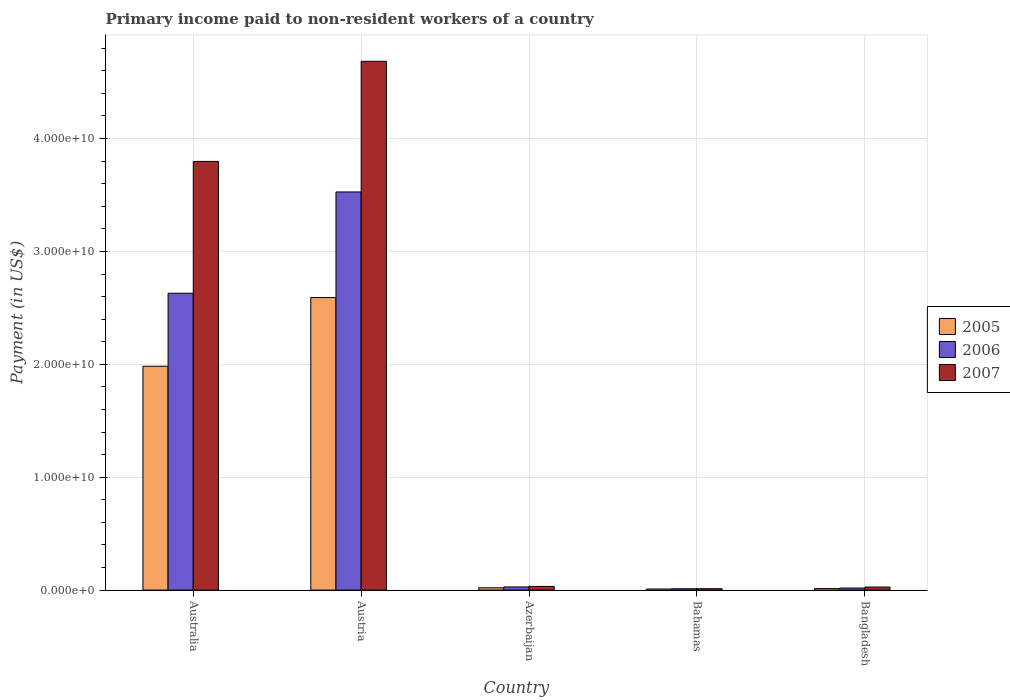How many groups of bars are there?
Provide a short and direct response. 5. Are the number of bars on each tick of the X-axis equal?
Offer a terse response. Yes. What is the label of the 4th group of bars from the left?
Keep it short and to the point. Bahamas. What is the amount paid to workers in 2006 in Bangladesh?
Offer a very short reply. 1.84e+08. Across all countries, what is the maximum amount paid to workers in 2007?
Offer a very short reply. 4.68e+1. Across all countries, what is the minimum amount paid to workers in 2006?
Ensure brevity in your answer.  1.19e+08. In which country was the amount paid to workers in 2007 maximum?
Make the answer very short. Austria. In which country was the amount paid to workers in 2007 minimum?
Ensure brevity in your answer.  Bahamas. What is the total amount paid to workers in 2005 in the graph?
Ensure brevity in your answer.  4.62e+1. What is the difference between the amount paid to workers in 2006 in Austria and that in Bahamas?
Offer a terse response. 3.52e+1. What is the difference between the amount paid to workers in 2006 in Azerbaijan and the amount paid to workers in 2007 in Bangladesh?
Ensure brevity in your answer.  8.32e+06. What is the average amount paid to workers in 2007 per country?
Make the answer very short. 1.71e+1. What is the difference between the amount paid to workers of/in 2006 and amount paid to workers of/in 2005 in Bangladesh?
Ensure brevity in your answer.  4.93e+07. What is the ratio of the amount paid to workers in 2005 in Bahamas to that in Bangladesh?
Your response must be concise. 0.72. Is the amount paid to workers in 2006 in Bahamas less than that in Bangladesh?
Offer a terse response. Yes. Is the difference between the amount paid to workers in 2006 in Austria and Bangladesh greater than the difference between the amount paid to workers in 2005 in Austria and Bangladesh?
Give a very brief answer. Yes. What is the difference between the highest and the second highest amount paid to workers in 2007?
Make the answer very short. 3.76e+1. What is the difference between the highest and the lowest amount paid to workers in 2005?
Make the answer very short. 2.58e+1. In how many countries, is the amount paid to workers in 2006 greater than the average amount paid to workers in 2006 taken over all countries?
Offer a very short reply. 2. Is the sum of the amount paid to workers in 2005 in Australia and Austria greater than the maximum amount paid to workers in 2007 across all countries?
Ensure brevity in your answer.  No. What does the 1st bar from the left in Australia represents?
Offer a terse response. 2005. What does the 3rd bar from the right in Austria represents?
Keep it short and to the point. 2005. Is it the case that in every country, the sum of the amount paid to workers in 2006 and amount paid to workers in 2005 is greater than the amount paid to workers in 2007?
Offer a very short reply. Yes. How many bars are there?
Your answer should be compact. 15. Are all the bars in the graph horizontal?
Provide a succinct answer. No. How many countries are there in the graph?
Provide a succinct answer. 5. What is the difference between two consecutive major ticks on the Y-axis?
Keep it short and to the point. 1.00e+1. Are the values on the major ticks of Y-axis written in scientific E-notation?
Ensure brevity in your answer.  Yes. Does the graph contain any zero values?
Ensure brevity in your answer.  No. Does the graph contain grids?
Ensure brevity in your answer.  Yes. How are the legend labels stacked?
Make the answer very short. Vertical. What is the title of the graph?
Provide a succinct answer. Primary income paid to non-resident workers of a country. What is the label or title of the Y-axis?
Give a very brief answer. Payment (in US$). What is the Payment (in US$) in 2005 in Australia?
Your answer should be compact. 1.98e+1. What is the Payment (in US$) of 2006 in Australia?
Keep it short and to the point. 2.63e+1. What is the Payment (in US$) of 2007 in Australia?
Provide a succinct answer. 3.80e+1. What is the Payment (in US$) in 2005 in Austria?
Give a very brief answer. 2.59e+1. What is the Payment (in US$) in 2006 in Austria?
Provide a succinct answer. 3.53e+1. What is the Payment (in US$) in 2007 in Austria?
Give a very brief answer. 4.68e+1. What is the Payment (in US$) in 2005 in Azerbaijan?
Offer a terse response. 2.02e+08. What is the Payment (in US$) in 2006 in Azerbaijan?
Offer a terse response. 2.80e+08. What is the Payment (in US$) of 2007 in Azerbaijan?
Your answer should be very brief. 3.28e+08. What is the Payment (in US$) of 2005 in Bahamas?
Offer a terse response. 9.70e+07. What is the Payment (in US$) in 2006 in Bahamas?
Ensure brevity in your answer.  1.19e+08. What is the Payment (in US$) in 2007 in Bahamas?
Offer a terse response. 1.21e+08. What is the Payment (in US$) of 2005 in Bangladesh?
Provide a succinct answer. 1.35e+08. What is the Payment (in US$) in 2006 in Bangladesh?
Provide a short and direct response. 1.84e+08. What is the Payment (in US$) in 2007 in Bangladesh?
Provide a short and direct response. 2.72e+08. Across all countries, what is the maximum Payment (in US$) in 2005?
Make the answer very short. 2.59e+1. Across all countries, what is the maximum Payment (in US$) in 2006?
Give a very brief answer. 3.53e+1. Across all countries, what is the maximum Payment (in US$) of 2007?
Offer a terse response. 4.68e+1. Across all countries, what is the minimum Payment (in US$) of 2005?
Make the answer very short. 9.70e+07. Across all countries, what is the minimum Payment (in US$) in 2006?
Your answer should be very brief. 1.19e+08. Across all countries, what is the minimum Payment (in US$) in 2007?
Ensure brevity in your answer.  1.21e+08. What is the total Payment (in US$) of 2005 in the graph?
Give a very brief answer. 4.62e+1. What is the total Payment (in US$) of 2006 in the graph?
Offer a very short reply. 6.22e+1. What is the total Payment (in US$) in 2007 in the graph?
Give a very brief answer. 8.55e+1. What is the difference between the Payment (in US$) of 2005 in Australia and that in Austria?
Provide a short and direct response. -6.09e+09. What is the difference between the Payment (in US$) of 2006 in Australia and that in Austria?
Offer a terse response. -8.97e+09. What is the difference between the Payment (in US$) of 2007 in Australia and that in Austria?
Give a very brief answer. -8.87e+09. What is the difference between the Payment (in US$) of 2005 in Australia and that in Azerbaijan?
Your response must be concise. 1.96e+1. What is the difference between the Payment (in US$) of 2006 in Australia and that in Azerbaijan?
Provide a succinct answer. 2.60e+1. What is the difference between the Payment (in US$) in 2007 in Australia and that in Azerbaijan?
Provide a short and direct response. 3.76e+1. What is the difference between the Payment (in US$) in 2005 in Australia and that in Bahamas?
Your answer should be compact. 1.97e+1. What is the difference between the Payment (in US$) of 2006 in Australia and that in Bahamas?
Offer a very short reply. 2.62e+1. What is the difference between the Payment (in US$) of 2007 in Australia and that in Bahamas?
Make the answer very short. 3.79e+1. What is the difference between the Payment (in US$) in 2005 in Australia and that in Bangladesh?
Offer a very short reply. 1.97e+1. What is the difference between the Payment (in US$) of 2006 in Australia and that in Bangladesh?
Your answer should be very brief. 2.61e+1. What is the difference between the Payment (in US$) of 2007 in Australia and that in Bangladesh?
Give a very brief answer. 3.77e+1. What is the difference between the Payment (in US$) in 2005 in Austria and that in Azerbaijan?
Provide a succinct answer. 2.57e+1. What is the difference between the Payment (in US$) in 2006 in Austria and that in Azerbaijan?
Offer a terse response. 3.50e+1. What is the difference between the Payment (in US$) of 2007 in Austria and that in Azerbaijan?
Your answer should be very brief. 4.65e+1. What is the difference between the Payment (in US$) in 2005 in Austria and that in Bahamas?
Provide a short and direct response. 2.58e+1. What is the difference between the Payment (in US$) of 2006 in Austria and that in Bahamas?
Your answer should be very brief. 3.52e+1. What is the difference between the Payment (in US$) in 2007 in Austria and that in Bahamas?
Provide a succinct answer. 4.67e+1. What is the difference between the Payment (in US$) of 2005 in Austria and that in Bangladesh?
Make the answer very short. 2.58e+1. What is the difference between the Payment (in US$) in 2006 in Austria and that in Bangladesh?
Offer a very short reply. 3.51e+1. What is the difference between the Payment (in US$) of 2007 in Austria and that in Bangladesh?
Give a very brief answer. 4.66e+1. What is the difference between the Payment (in US$) in 2005 in Azerbaijan and that in Bahamas?
Your answer should be compact. 1.05e+08. What is the difference between the Payment (in US$) in 2006 in Azerbaijan and that in Bahamas?
Make the answer very short. 1.61e+08. What is the difference between the Payment (in US$) in 2007 in Azerbaijan and that in Bahamas?
Make the answer very short. 2.07e+08. What is the difference between the Payment (in US$) in 2005 in Azerbaijan and that in Bangladesh?
Offer a terse response. 6.66e+07. What is the difference between the Payment (in US$) in 2006 in Azerbaijan and that in Bangladesh?
Your answer should be compact. 9.56e+07. What is the difference between the Payment (in US$) of 2007 in Azerbaijan and that in Bangladesh?
Your answer should be compact. 5.61e+07. What is the difference between the Payment (in US$) in 2005 in Bahamas and that in Bangladesh?
Provide a short and direct response. -3.82e+07. What is the difference between the Payment (in US$) of 2006 in Bahamas and that in Bangladesh?
Offer a very short reply. -6.50e+07. What is the difference between the Payment (in US$) in 2007 in Bahamas and that in Bangladesh?
Your answer should be very brief. -1.50e+08. What is the difference between the Payment (in US$) of 2005 in Australia and the Payment (in US$) of 2006 in Austria?
Your answer should be very brief. -1.54e+1. What is the difference between the Payment (in US$) of 2005 in Australia and the Payment (in US$) of 2007 in Austria?
Provide a short and direct response. -2.70e+1. What is the difference between the Payment (in US$) of 2006 in Australia and the Payment (in US$) of 2007 in Austria?
Provide a short and direct response. -2.05e+1. What is the difference between the Payment (in US$) of 2005 in Australia and the Payment (in US$) of 2006 in Azerbaijan?
Keep it short and to the point. 1.95e+1. What is the difference between the Payment (in US$) in 2005 in Australia and the Payment (in US$) in 2007 in Azerbaijan?
Provide a short and direct response. 1.95e+1. What is the difference between the Payment (in US$) in 2006 in Australia and the Payment (in US$) in 2007 in Azerbaijan?
Your response must be concise. 2.60e+1. What is the difference between the Payment (in US$) of 2005 in Australia and the Payment (in US$) of 2006 in Bahamas?
Your answer should be compact. 1.97e+1. What is the difference between the Payment (in US$) of 2005 in Australia and the Payment (in US$) of 2007 in Bahamas?
Offer a very short reply. 1.97e+1. What is the difference between the Payment (in US$) in 2006 in Australia and the Payment (in US$) in 2007 in Bahamas?
Give a very brief answer. 2.62e+1. What is the difference between the Payment (in US$) of 2005 in Australia and the Payment (in US$) of 2006 in Bangladesh?
Your answer should be very brief. 1.96e+1. What is the difference between the Payment (in US$) of 2005 in Australia and the Payment (in US$) of 2007 in Bangladesh?
Offer a very short reply. 1.96e+1. What is the difference between the Payment (in US$) in 2006 in Australia and the Payment (in US$) in 2007 in Bangladesh?
Provide a succinct answer. 2.60e+1. What is the difference between the Payment (in US$) in 2005 in Austria and the Payment (in US$) in 2006 in Azerbaijan?
Make the answer very short. 2.56e+1. What is the difference between the Payment (in US$) in 2005 in Austria and the Payment (in US$) in 2007 in Azerbaijan?
Keep it short and to the point. 2.56e+1. What is the difference between the Payment (in US$) of 2006 in Austria and the Payment (in US$) of 2007 in Azerbaijan?
Offer a terse response. 3.49e+1. What is the difference between the Payment (in US$) of 2005 in Austria and the Payment (in US$) of 2006 in Bahamas?
Your response must be concise. 2.58e+1. What is the difference between the Payment (in US$) of 2005 in Austria and the Payment (in US$) of 2007 in Bahamas?
Give a very brief answer. 2.58e+1. What is the difference between the Payment (in US$) of 2006 in Austria and the Payment (in US$) of 2007 in Bahamas?
Your answer should be very brief. 3.51e+1. What is the difference between the Payment (in US$) in 2005 in Austria and the Payment (in US$) in 2006 in Bangladesh?
Give a very brief answer. 2.57e+1. What is the difference between the Payment (in US$) of 2005 in Austria and the Payment (in US$) of 2007 in Bangladesh?
Keep it short and to the point. 2.56e+1. What is the difference between the Payment (in US$) of 2006 in Austria and the Payment (in US$) of 2007 in Bangladesh?
Keep it short and to the point. 3.50e+1. What is the difference between the Payment (in US$) in 2005 in Azerbaijan and the Payment (in US$) in 2006 in Bahamas?
Your response must be concise. 8.24e+07. What is the difference between the Payment (in US$) in 2005 in Azerbaijan and the Payment (in US$) in 2007 in Bahamas?
Make the answer very short. 8.05e+07. What is the difference between the Payment (in US$) of 2006 in Azerbaijan and the Payment (in US$) of 2007 in Bahamas?
Keep it short and to the point. 1.59e+08. What is the difference between the Payment (in US$) in 2005 in Azerbaijan and the Payment (in US$) in 2006 in Bangladesh?
Your response must be concise. 1.74e+07. What is the difference between the Payment (in US$) of 2005 in Azerbaijan and the Payment (in US$) of 2007 in Bangladesh?
Provide a succinct answer. -6.99e+07. What is the difference between the Payment (in US$) in 2006 in Azerbaijan and the Payment (in US$) in 2007 in Bangladesh?
Your answer should be very brief. 8.32e+06. What is the difference between the Payment (in US$) of 2005 in Bahamas and the Payment (in US$) of 2006 in Bangladesh?
Give a very brief answer. -8.74e+07. What is the difference between the Payment (in US$) of 2005 in Bahamas and the Payment (in US$) of 2007 in Bangladesh?
Ensure brevity in your answer.  -1.75e+08. What is the difference between the Payment (in US$) in 2006 in Bahamas and the Payment (in US$) in 2007 in Bangladesh?
Make the answer very short. -1.52e+08. What is the average Payment (in US$) of 2005 per country?
Your response must be concise. 9.24e+09. What is the average Payment (in US$) in 2006 per country?
Your answer should be very brief. 1.24e+1. What is the average Payment (in US$) in 2007 per country?
Your response must be concise. 1.71e+1. What is the difference between the Payment (in US$) of 2005 and Payment (in US$) of 2006 in Australia?
Make the answer very short. -6.47e+09. What is the difference between the Payment (in US$) of 2005 and Payment (in US$) of 2007 in Australia?
Provide a short and direct response. -1.81e+1. What is the difference between the Payment (in US$) of 2006 and Payment (in US$) of 2007 in Australia?
Ensure brevity in your answer.  -1.17e+1. What is the difference between the Payment (in US$) of 2005 and Payment (in US$) of 2006 in Austria?
Give a very brief answer. -9.36e+09. What is the difference between the Payment (in US$) of 2005 and Payment (in US$) of 2007 in Austria?
Your answer should be very brief. -2.09e+1. What is the difference between the Payment (in US$) of 2006 and Payment (in US$) of 2007 in Austria?
Your response must be concise. -1.16e+1. What is the difference between the Payment (in US$) of 2005 and Payment (in US$) of 2006 in Azerbaijan?
Provide a succinct answer. -7.82e+07. What is the difference between the Payment (in US$) in 2005 and Payment (in US$) in 2007 in Azerbaijan?
Your answer should be very brief. -1.26e+08. What is the difference between the Payment (in US$) in 2006 and Payment (in US$) in 2007 in Azerbaijan?
Your answer should be compact. -4.78e+07. What is the difference between the Payment (in US$) in 2005 and Payment (in US$) in 2006 in Bahamas?
Offer a terse response. -2.24e+07. What is the difference between the Payment (in US$) in 2005 and Payment (in US$) in 2007 in Bahamas?
Make the answer very short. -2.43e+07. What is the difference between the Payment (in US$) in 2006 and Payment (in US$) in 2007 in Bahamas?
Make the answer very short. -1.88e+06. What is the difference between the Payment (in US$) of 2005 and Payment (in US$) of 2006 in Bangladesh?
Offer a very short reply. -4.93e+07. What is the difference between the Payment (in US$) of 2005 and Payment (in US$) of 2007 in Bangladesh?
Provide a succinct answer. -1.37e+08. What is the difference between the Payment (in US$) of 2006 and Payment (in US$) of 2007 in Bangladesh?
Your response must be concise. -8.73e+07. What is the ratio of the Payment (in US$) of 2005 in Australia to that in Austria?
Give a very brief answer. 0.77. What is the ratio of the Payment (in US$) in 2006 in Australia to that in Austria?
Make the answer very short. 0.75. What is the ratio of the Payment (in US$) in 2007 in Australia to that in Austria?
Your response must be concise. 0.81. What is the ratio of the Payment (in US$) of 2005 in Australia to that in Azerbaijan?
Give a very brief answer. 98.25. What is the ratio of the Payment (in US$) of 2006 in Australia to that in Azerbaijan?
Offer a very short reply. 93.92. What is the ratio of the Payment (in US$) in 2007 in Australia to that in Azerbaijan?
Give a very brief answer. 115.86. What is the ratio of the Payment (in US$) of 2005 in Australia to that in Bahamas?
Make the answer very short. 204.44. What is the ratio of the Payment (in US$) of 2006 in Australia to that in Bahamas?
Offer a terse response. 220.27. What is the ratio of the Payment (in US$) in 2007 in Australia to that in Bahamas?
Give a very brief answer. 313.15. What is the ratio of the Payment (in US$) of 2005 in Australia to that in Bangladesh?
Your answer should be compact. 146.7. What is the ratio of the Payment (in US$) in 2006 in Australia to that in Bangladesh?
Your answer should be very brief. 142.59. What is the ratio of the Payment (in US$) in 2007 in Australia to that in Bangladesh?
Give a very brief answer. 139.78. What is the ratio of the Payment (in US$) in 2005 in Austria to that in Azerbaijan?
Offer a terse response. 128.41. What is the ratio of the Payment (in US$) of 2006 in Austria to that in Azerbaijan?
Provide a short and direct response. 125.96. What is the ratio of the Payment (in US$) of 2007 in Austria to that in Azerbaijan?
Keep it short and to the point. 142.91. What is the ratio of the Payment (in US$) of 2005 in Austria to that in Bahamas?
Your answer should be compact. 267.18. What is the ratio of the Payment (in US$) of 2006 in Austria to that in Bahamas?
Provide a succinct answer. 295.41. What is the ratio of the Payment (in US$) in 2007 in Austria to that in Bahamas?
Provide a succinct answer. 386.27. What is the ratio of the Payment (in US$) in 2005 in Austria to that in Bangladesh?
Make the answer very short. 191.72. What is the ratio of the Payment (in US$) in 2006 in Austria to that in Bangladesh?
Offer a terse response. 191.23. What is the ratio of the Payment (in US$) of 2007 in Austria to that in Bangladesh?
Your response must be concise. 172.41. What is the ratio of the Payment (in US$) in 2005 in Azerbaijan to that in Bahamas?
Your response must be concise. 2.08. What is the ratio of the Payment (in US$) in 2006 in Azerbaijan to that in Bahamas?
Provide a short and direct response. 2.35. What is the ratio of the Payment (in US$) in 2007 in Azerbaijan to that in Bahamas?
Give a very brief answer. 2.7. What is the ratio of the Payment (in US$) in 2005 in Azerbaijan to that in Bangladesh?
Offer a very short reply. 1.49. What is the ratio of the Payment (in US$) of 2006 in Azerbaijan to that in Bangladesh?
Provide a succinct answer. 1.52. What is the ratio of the Payment (in US$) of 2007 in Azerbaijan to that in Bangladesh?
Provide a short and direct response. 1.21. What is the ratio of the Payment (in US$) of 2005 in Bahamas to that in Bangladesh?
Offer a very short reply. 0.72. What is the ratio of the Payment (in US$) in 2006 in Bahamas to that in Bangladesh?
Keep it short and to the point. 0.65. What is the ratio of the Payment (in US$) in 2007 in Bahamas to that in Bangladesh?
Your response must be concise. 0.45. What is the difference between the highest and the second highest Payment (in US$) of 2005?
Provide a short and direct response. 6.09e+09. What is the difference between the highest and the second highest Payment (in US$) of 2006?
Give a very brief answer. 8.97e+09. What is the difference between the highest and the second highest Payment (in US$) in 2007?
Ensure brevity in your answer.  8.87e+09. What is the difference between the highest and the lowest Payment (in US$) in 2005?
Keep it short and to the point. 2.58e+1. What is the difference between the highest and the lowest Payment (in US$) of 2006?
Your answer should be very brief. 3.52e+1. What is the difference between the highest and the lowest Payment (in US$) in 2007?
Provide a succinct answer. 4.67e+1. 